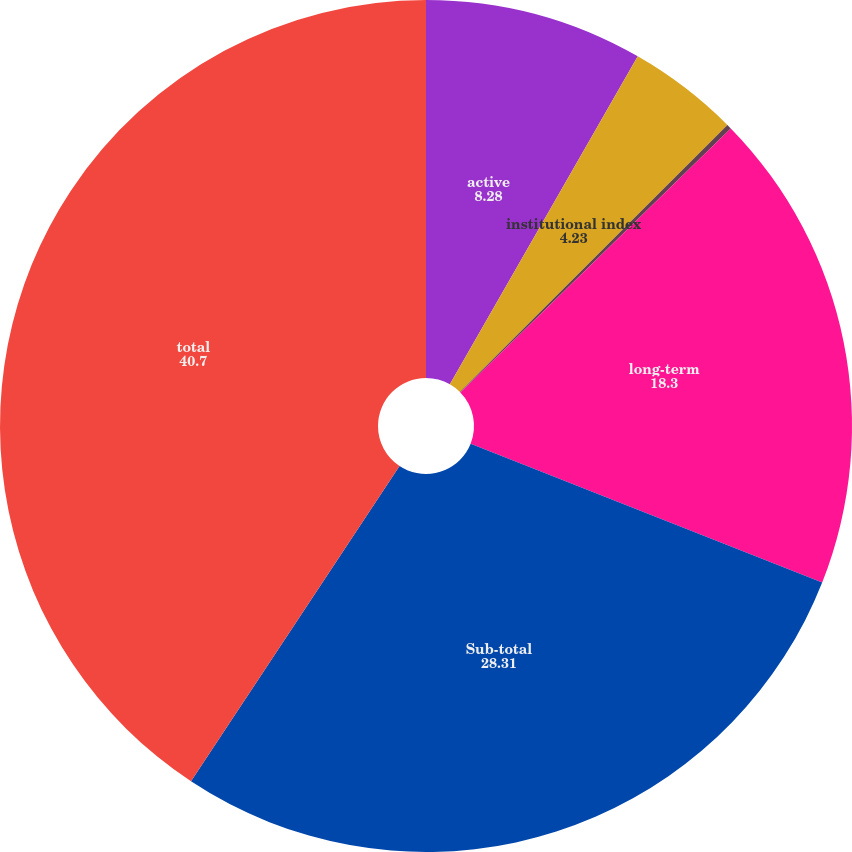Convert chart to OTSL. <chart><loc_0><loc_0><loc_500><loc_500><pie_chart><fcel>active<fcel>institutional index<fcel>core<fcel>long-term<fcel>Sub-total<fcel>total<nl><fcel>8.28%<fcel>4.23%<fcel>0.18%<fcel>18.3%<fcel>28.31%<fcel>40.7%<nl></chart> 